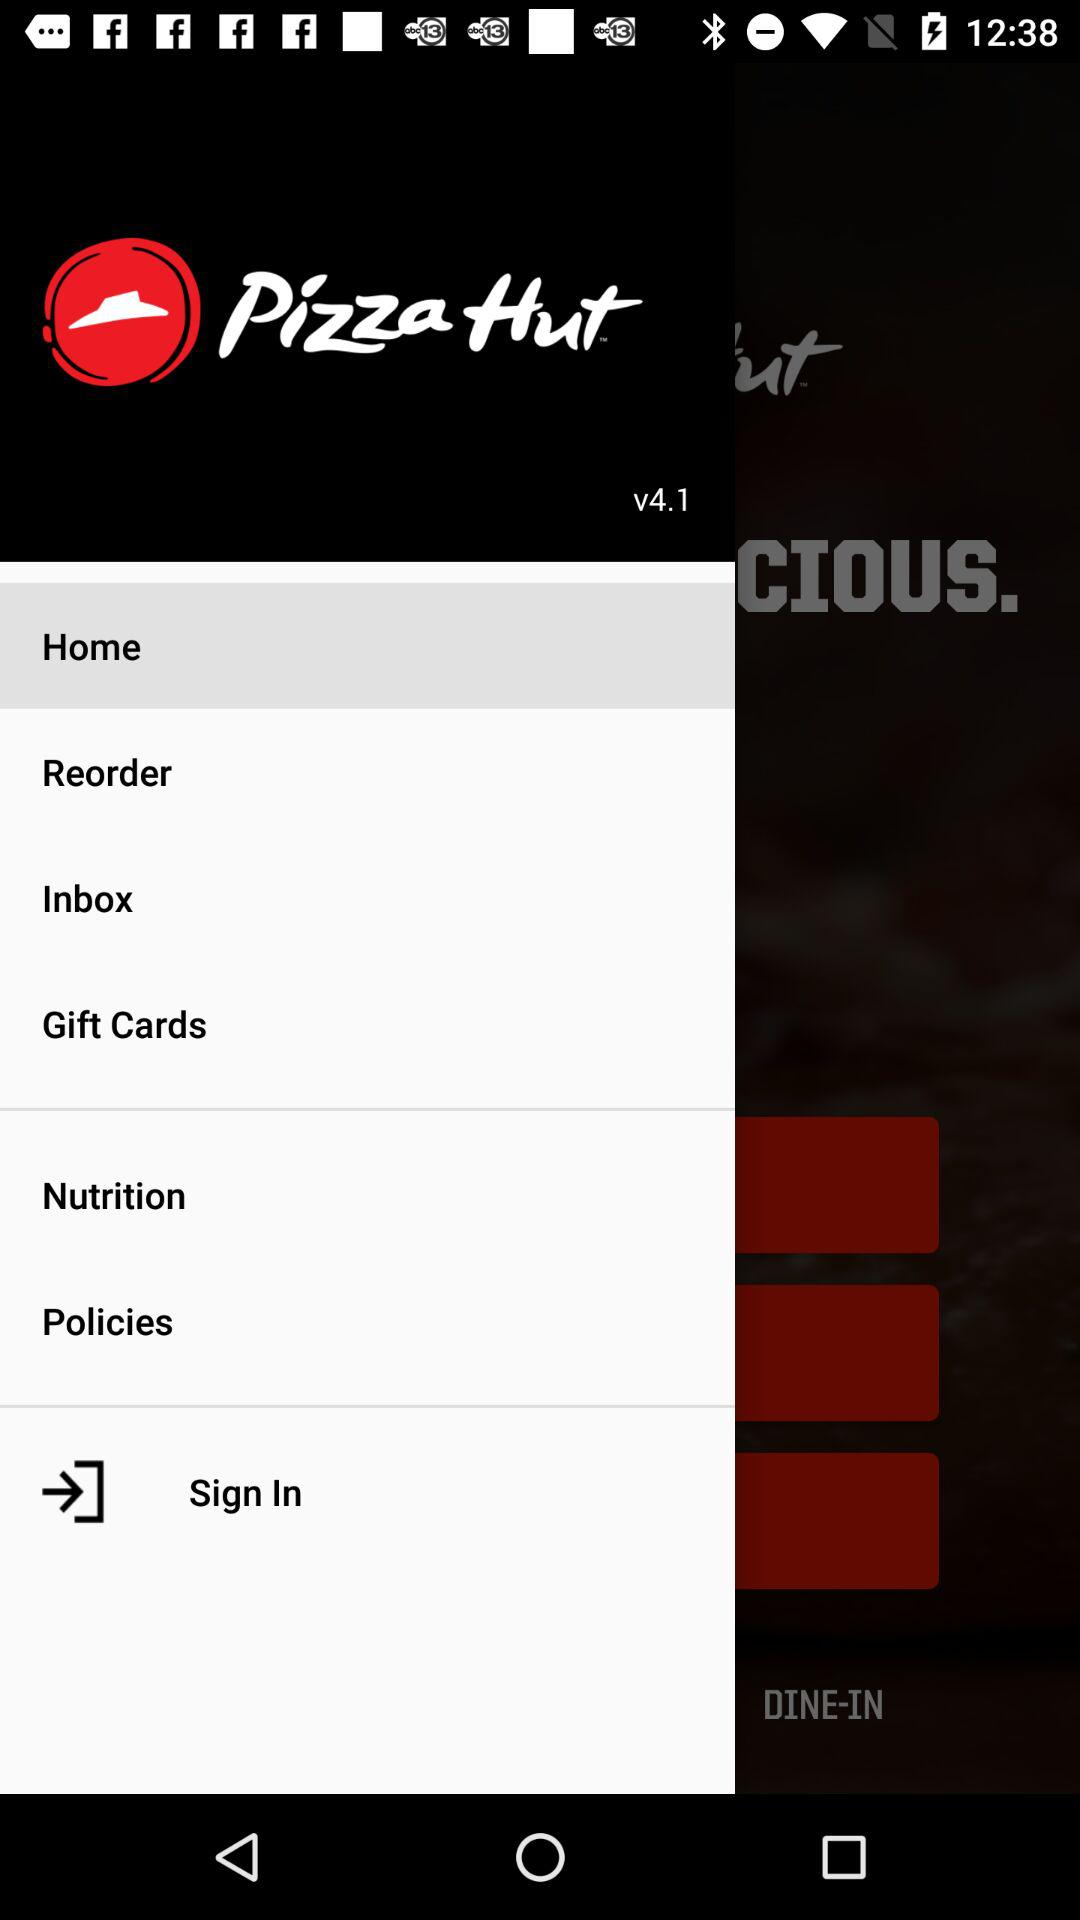Which tab is selected? The selected tab is "Home". 